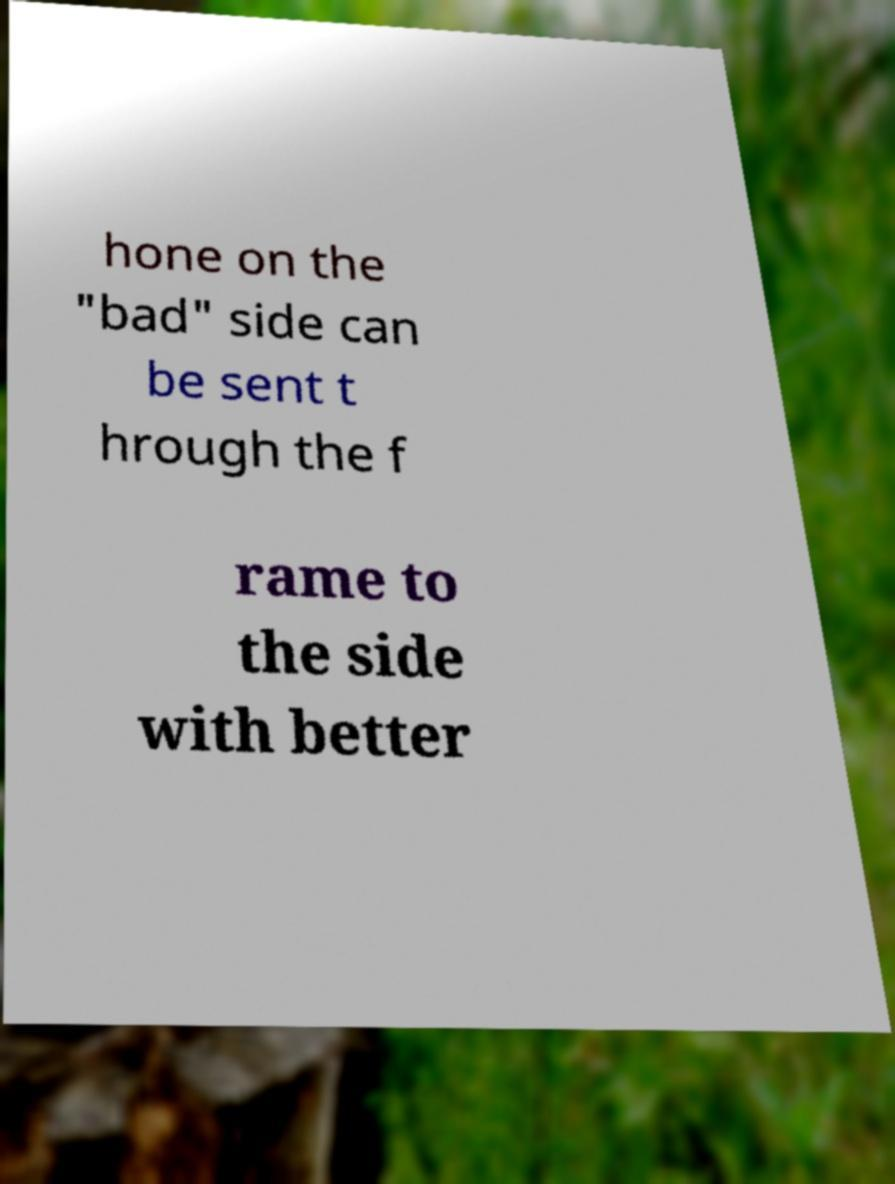Can you read and provide the text displayed in the image?This photo seems to have some interesting text. Can you extract and type it out for me? hone on the "bad" side can be sent t hrough the f rame to the side with better 